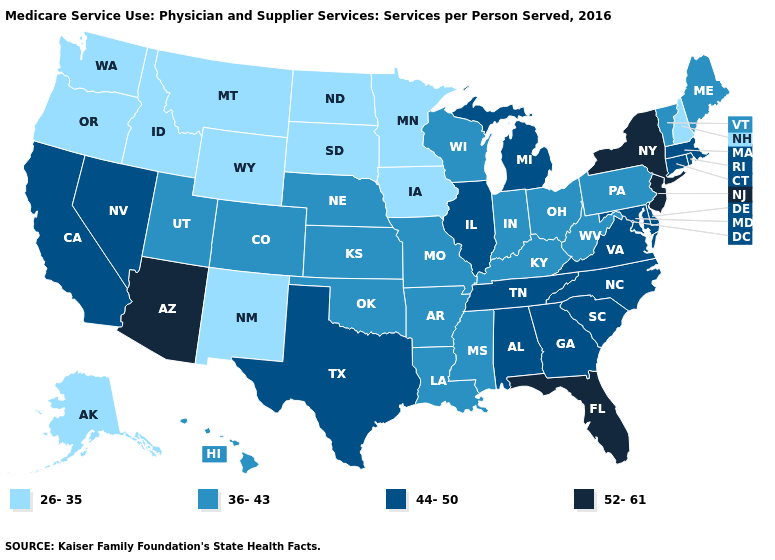What is the value of Ohio?
Give a very brief answer. 36-43. What is the value of Wisconsin?
Concise answer only. 36-43. Name the states that have a value in the range 36-43?
Keep it brief. Arkansas, Colorado, Hawaii, Indiana, Kansas, Kentucky, Louisiana, Maine, Mississippi, Missouri, Nebraska, Ohio, Oklahoma, Pennsylvania, Utah, Vermont, West Virginia, Wisconsin. Among the states that border Oklahoma , does New Mexico have the lowest value?
Give a very brief answer. Yes. Name the states that have a value in the range 44-50?
Answer briefly. Alabama, California, Connecticut, Delaware, Georgia, Illinois, Maryland, Massachusetts, Michigan, Nevada, North Carolina, Rhode Island, South Carolina, Tennessee, Texas, Virginia. Does the map have missing data?
Concise answer only. No. Among the states that border New Hampshire , which have the lowest value?
Concise answer only. Maine, Vermont. What is the lowest value in the West?
Be succinct. 26-35. Does Arizona have the highest value in the USA?
Be succinct. Yes. What is the lowest value in the South?
Answer briefly. 36-43. What is the highest value in states that border Missouri?
Answer briefly. 44-50. Name the states that have a value in the range 26-35?
Quick response, please. Alaska, Idaho, Iowa, Minnesota, Montana, New Hampshire, New Mexico, North Dakota, Oregon, South Dakota, Washington, Wyoming. What is the highest value in states that border Maryland?
Give a very brief answer. 44-50. Name the states that have a value in the range 36-43?
Quick response, please. Arkansas, Colorado, Hawaii, Indiana, Kansas, Kentucky, Louisiana, Maine, Mississippi, Missouri, Nebraska, Ohio, Oklahoma, Pennsylvania, Utah, Vermont, West Virginia, Wisconsin. Which states hav the highest value in the West?
Keep it brief. Arizona. 